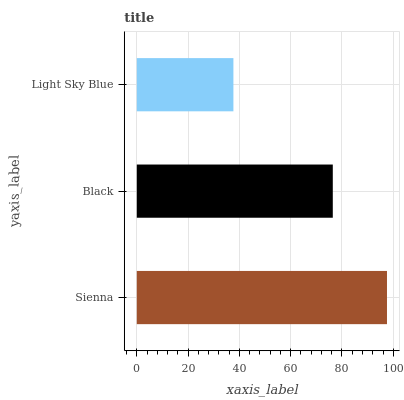Is Light Sky Blue the minimum?
Answer yes or no. Yes. Is Sienna the maximum?
Answer yes or no. Yes. Is Black the minimum?
Answer yes or no. No. Is Black the maximum?
Answer yes or no. No. Is Sienna greater than Black?
Answer yes or no. Yes. Is Black less than Sienna?
Answer yes or no. Yes. Is Black greater than Sienna?
Answer yes or no. No. Is Sienna less than Black?
Answer yes or no. No. Is Black the high median?
Answer yes or no. Yes. Is Black the low median?
Answer yes or no. Yes. Is Sienna the high median?
Answer yes or no. No. Is Light Sky Blue the low median?
Answer yes or no. No. 